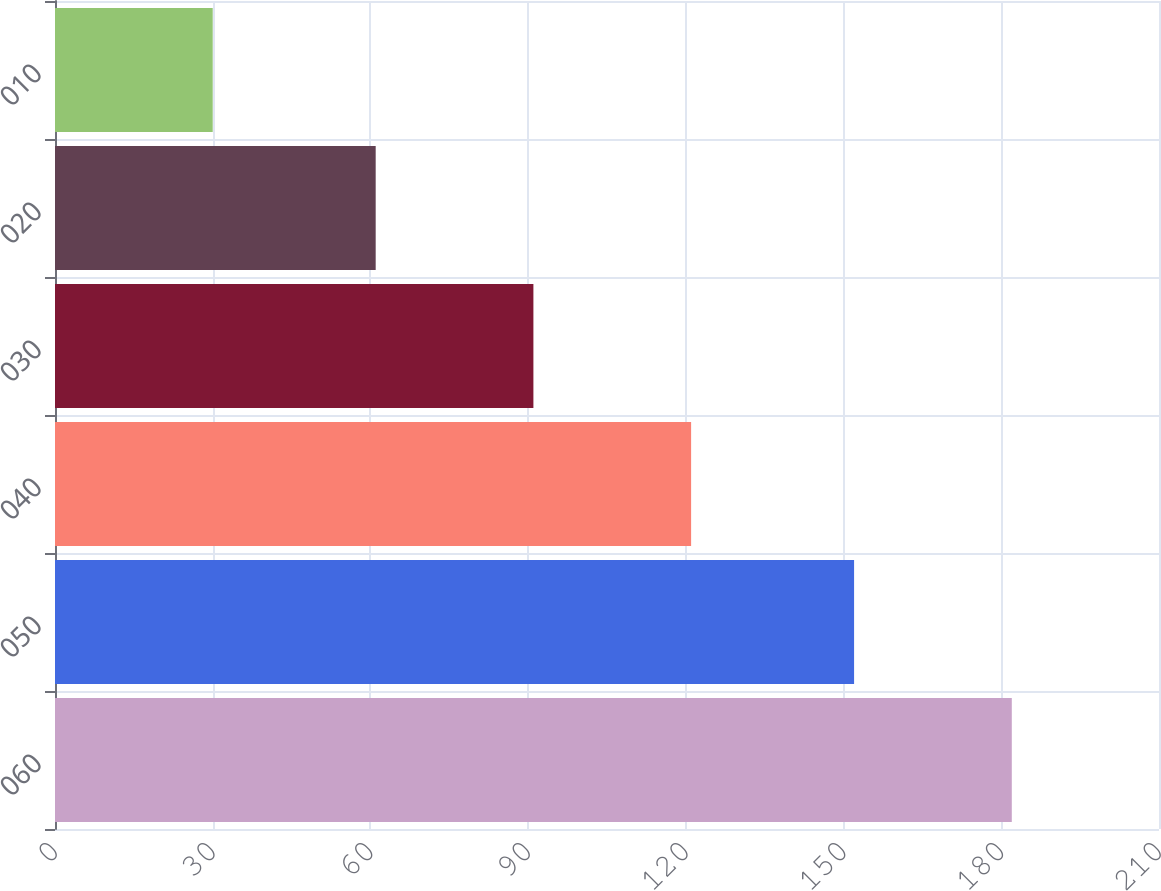Convert chart to OTSL. <chart><loc_0><loc_0><loc_500><loc_500><bar_chart><fcel>060<fcel>050<fcel>040<fcel>030<fcel>020<fcel>010<nl><fcel>182<fcel>152<fcel>121<fcel>91<fcel>61<fcel>30<nl></chart> 